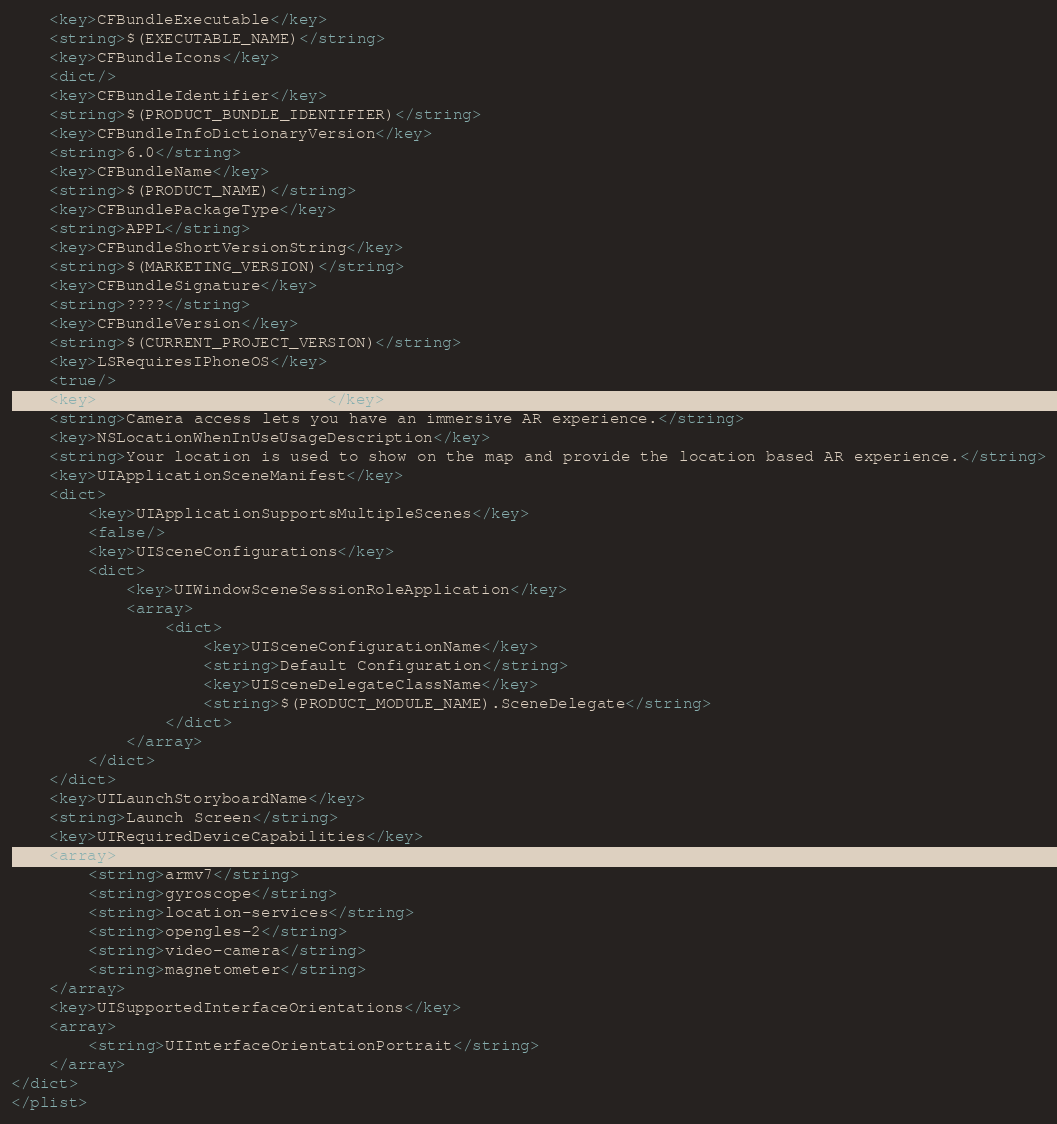Convert code to text. <code><loc_0><loc_0><loc_500><loc_500><_XML_>	<key>CFBundleExecutable</key>
	<string>$(EXECUTABLE_NAME)</string>
	<key>CFBundleIcons</key>
	<dict/>
	<key>CFBundleIdentifier</key>
	<string>$(PRODUCT_BUNDLE_IDENTIFIER)</string>
	<key>CFBundleInfoDictionaryVersion</key>
	<string>6.0</string>
	<key>CFBundleName</key>
	<string>$(PRODUCT_NAME)</string>
	<key>CFBundlePackageType</key>
	<string>APPL</string>
	<key>CFBundleShortVersionString</key>
	<string>$(MARKETING_VERSION)</string>
	<key>CFBundleSignature</key>
	<string>????</string>
	<key>CFBundleVersion</key>
	<string>$(CURRENT_PROJECT_VERSION)</string>
	<key>LSRequiresIPhoneOS</key>
	<true/>
	<key>NSCameraUsageDescription</key>
	<string>Camera access lets you have an immersive AR experience.</string>
	<key>NSLocationWhenInUseUsageDescription</key>
	<string>Your location is used to show on the map and provide the location based AR experience.</string>
	<key>UIApplicationSceneManifest</key>
	<dict>
		<key>UIApplicationSupportsMultipleScenes</key>
		<false/>
		<key>UISceneConfigurations</key>
		<dict>
			<key>UIWindowSceneSessionRoleApplication</key>
			<array>
				<dict>
					<key>UISceneConfigurationName</key>
					<string>Default Configuration</string>
					<key>UISceneDelegateClassName</key>
					<string>$(PRODUCT_MODULE_NAME).SceneDelegate</string>
				</dict>
			</array>
		</dict>
	</dict>
	<key>UILaunchStoryboardName</key>
	<string>Launch Screen</string>
	<key>UIRequiredDeviceCapabilities</key>
	<array>
		<string>armv7</string>
		<string>gyroscope</string>
		<string>location-services</string>
		<string>opengles-2</string>
		<string>video-camera</string>
		<string>magnetometer</string>
	</array>
	<key>UISupportedInterfaceOrientations</key>
	<array>
		<string>UIInterfaceOrientationPortrait</string>
	</array>
</dict>
</plist>
</code> 